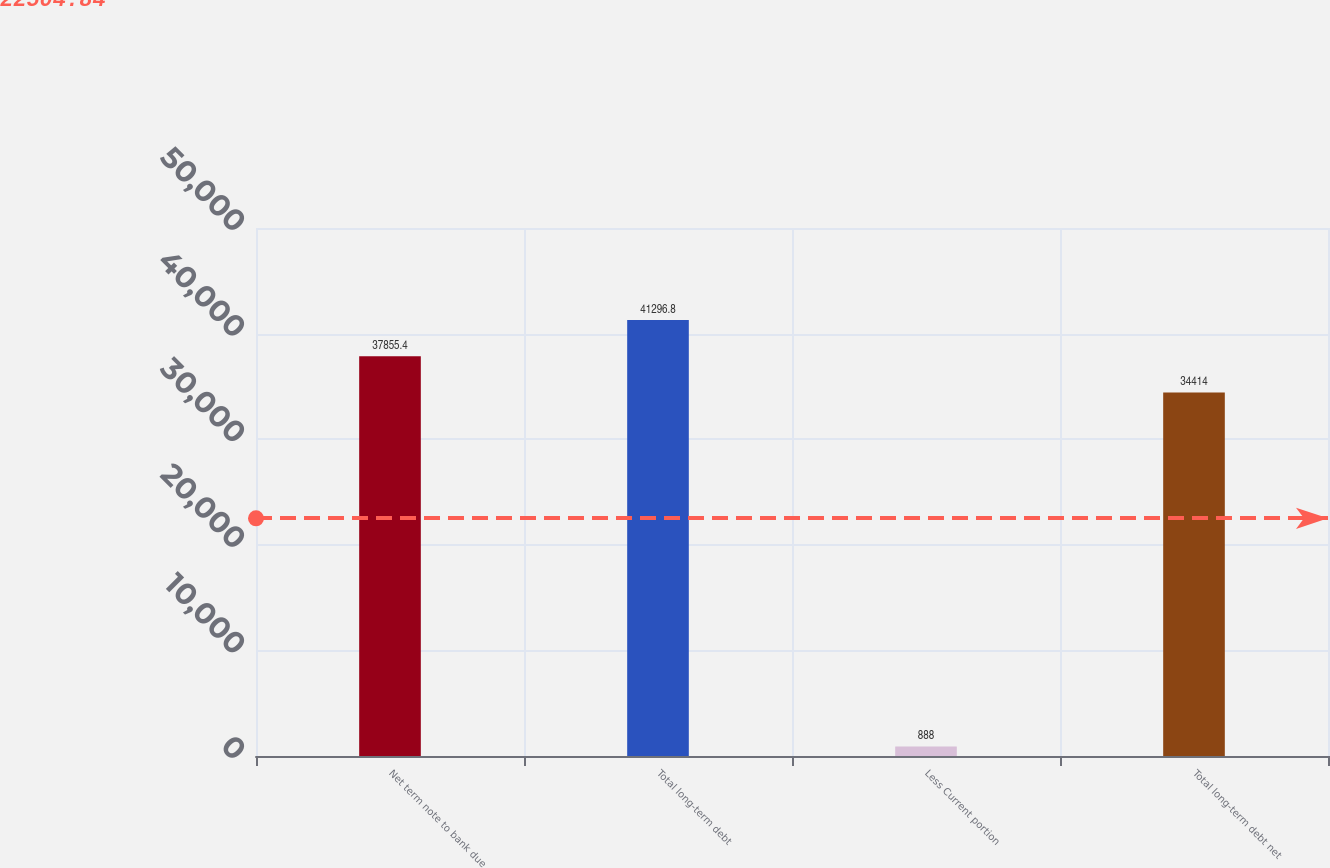Convert chart. <chart><loc_0><loc_0><loc_500><loc_500><bar_chart><fcel>Net term note to bank due<fcel>Total long-term debt<fcel>Less Current portion<fcel>Total long-term debt net<nl><fcel>37855.4<fcel>41296.8<fcel>888<fcel>34414<nl></chart> 